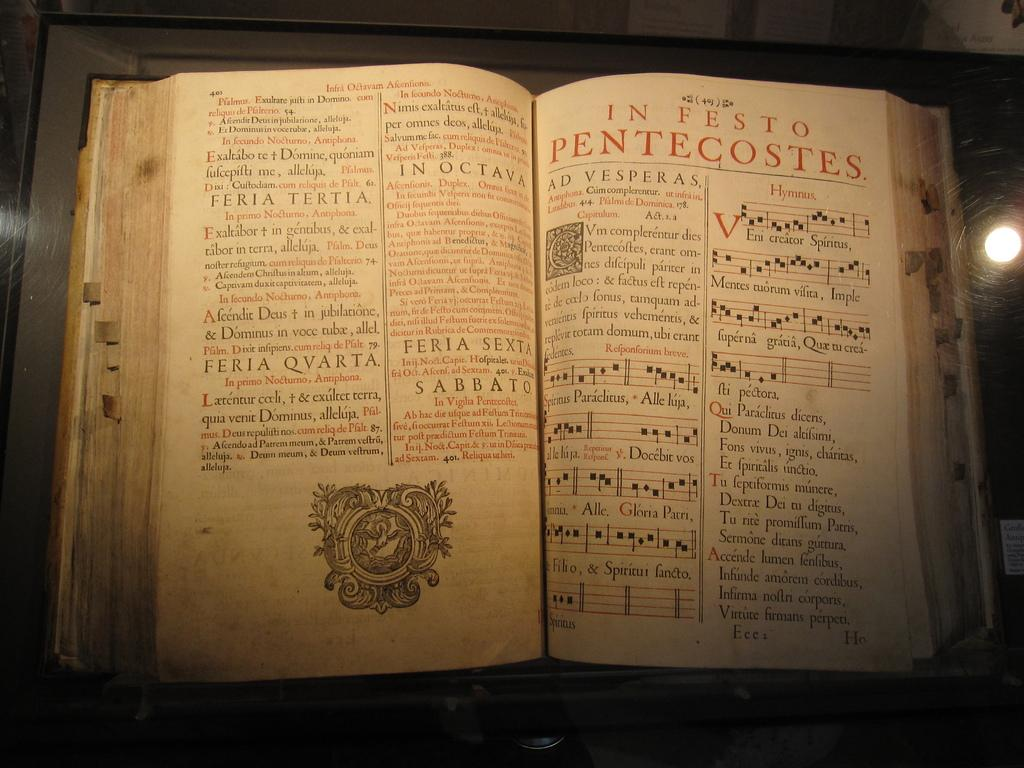<image>
Share a concise interpretation of the image provided. an old open book to the chapter in festo pentecostes 